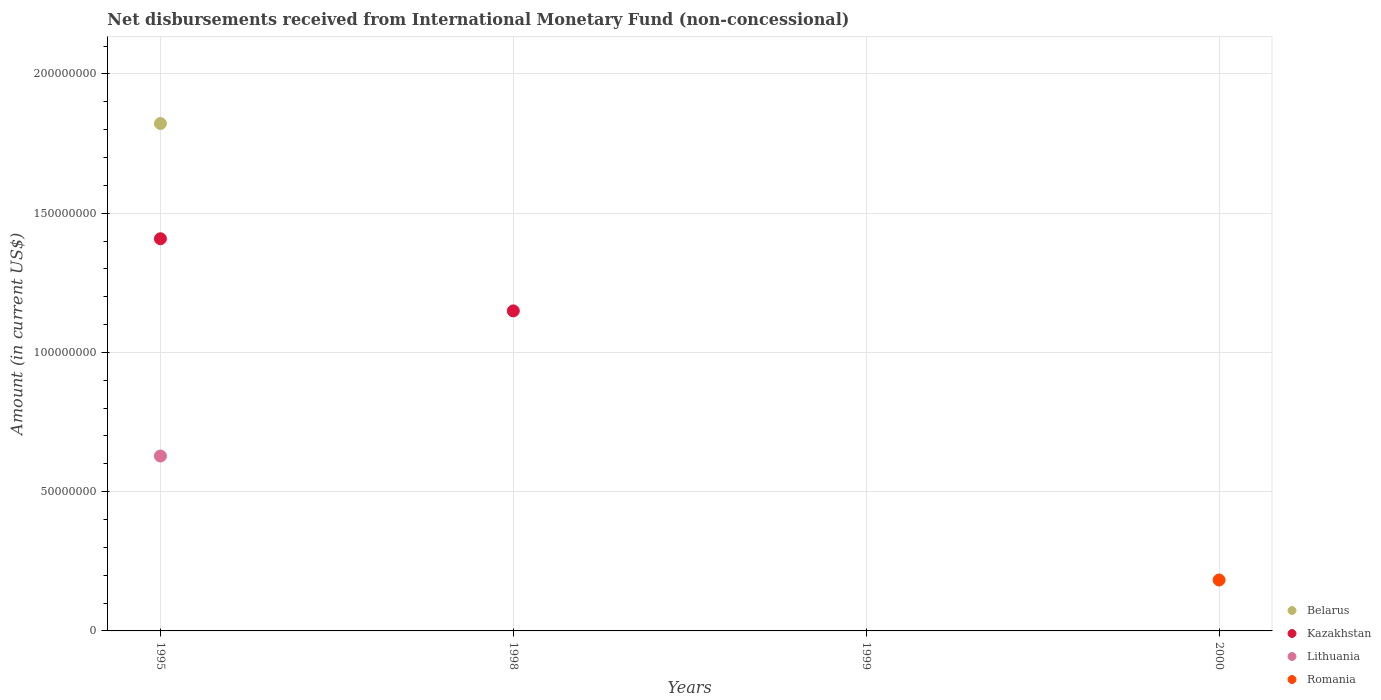Is the number of dotlines equal to the number of legend labels?
Offer a terse response. No. What is the amount of disbursements received from International Monetary Fund in Lithuania in 2000?
Your answer should be compact. 0. Across all years, what is the maximum amount of disbursements received from International Monetary Fund in Romania?
Keep it short and to the point. 1.83e+07. Across all years, what is the minimum amount of disbursements received from International Monetary Fund in Kazakhstan?
Your response must be concise. 0. In which year was the amount of disbursements received from International Monetary Fund in Romania maximum?
Keep it short and to the point. 2000. What is the total amount of disbursements received from International Monetary Fund in Kazakhstan in the graph?
Your answer should be very brief. 2.56e+08. What is the difference between the amount of disbursements received from International Monetary Fund in Kazakhstan in 1995 and that in 1998?
Offer a very short reply. 2.59e+07. What is the difference between the amount of disbursements received from International Monetary Fund in Lithuania in 1998 and the amount of disbursements received from International Monetary Fund in Romania in 2000?
Your response must be concise. -1.83e+07. What is the average amount of disbursements received from International Monetary Fund in Lithuania per year?
Provide a succinct answer. 1.57e+07. In the year 1995, what is the difference between the amount of disbursements received from International Monetary Fund in Belarus and amount of disbursements received from International Monetary Fund in Kazakhstan?
Your answer should be compact. 4.14e+07. What is the difference between the highest and the lowest amount of disbursements received from International Monetary Fund in Kazakhstan?
Your answer should be compact. 1.41e+08. Is it the case that in every year, the sum of the amount of disbursements received from International Monetary Fund in Romania and amount of disbursements received from International Monetary Fund in Belarus  is greater than the amount of disbursements received from International Monetary Fund in Lithuania?
Make the answer very short. No. Does the amount of disbursements received from International Monetary Fund in Belarus monotonically increase over the years?
Offer a terse response. No. Is the amount of disbursements received from International Monetary Fund in Kazakhstan strictly less than the amount of disbursements received from International Monetary Fund in Belarus over the years?
Make the answer very short. No. How many dotlines are there?
Offer a very short reply. 4. How many years are there in the graph?
Ensure brevity in your answer.  4. Does the graph contain grids?
Give a very brief answer. Yes. How many legend labels are there?
Give a very brief answer. 4. What is the title of the graph?
Give a very brief answer. Net disbursements received from International Monetary Fund (non-concessional). What is the label or title of the X-axis?
Give a very brief answer. Years. What is the label or title of the Y-axis?
Provide a succinct answer. Amount (in current US$). What is the Amount (in current US$) of Belarus in 1995?
Offer a very short reply. 1.82e+08. What is the Amount (in current US$) of Kazakhstan in 1995?
Your answer should be compact. 1.41e+08. What is the Amount (in current US$) of Lithuania in 1995?
Ensure brevity in your answer.  6.28e+07. What is the Amount (in current US$) of Romania in 1995?
Your response must be concise. 0. What is the Amount (in current US$) in Kazakhstan in 1998?
Offer a terse response. 1.15e+08. What is the Amount (in current US$) of Lithuania in 1998?
Your response must be concise. 0. What is the Amount (in current US$) of Romania in 1998?
Provide a succinct answer. 0. What is the Amount (in current US$) in Belarus in 1999?
Offer a very short reply. 0. What is the Amount (in current US$) in Kazakhstan in 1999?
Your answer should be compact. 0. What is the Amount (in current US$) in Lithuania in 1999?
Provide a short and direct response. 0. What is the Amount (in current US$) of Romania in 1999?
Give a very brief answer. 0. What is the Amount (in current US$) in Belarus in 2000?
Provide a short and direct response. 0. What is the Amount (in current US$) in Kazakhstan in 2000?
Your answer should be very brief. 0. What is the Amount (in current US$) in Romania in 2000?
Provide a succinct answer. 1.83e+07. Across all years, what is the maximum Amount (in current US$) of Belarus?
Provide a short and direct response. 1.82e+08. Across all years, what is the maximum Amount (in current US$) of Kazakhstan?
Make the answer very short. 1.41e+08. Across all years, what is the maximum Amount (in current US$) of Lithuania?
Give a very brief answer. 6.28e+07. Across all years, what is the maximum Amount (in current US$) in Romania?
Your answer should be compact. 1.83e+07. Across all years, what is the minimum Amount (in current US$) of Lithuania?
Offer a very short reply. 0. Across all years, what is the minimum Amount (in current US$) of Romania?
Keep it short and to the point. 0. What is the total Amount (in current US$) of Belarus in the graph?
Your answer should be very brief. 1.82e+08. What is the total Amount (in current US$) of Kazakhstan in the graph?
Keep it short and to the point. 2.56e+08. What is the total Amount (in current US$) in Lithuania in the graph?
Make the answer very short. 6.28e+07. What is the total Amount (in current US$) in Romania in the graph?
Give a very brief answer. 1.83e+07. What is the difference between the Amount (in current US$) of Kazakhstan in 1995 and that in 1998?
Ensure brevity in your answer.  2.59e+07. What is the difference between the Amount (in current US$) in Belarus in 1995 and the Amount (in current US$) in Kazakhstan in 1998?
Provide a short and direct response. 6.73e+07. What is the difference between the Amount (in current US$) in Belarus in 1995 and the Amount (in current US$) in Romania in 2000?
Give a very brief answer. 1.64e+08. What is the difference between the Amount (in current US$) of Kazakhstan in 1995 and the Amount (in current US$) of Romania in 2000?
Ensure brevity in your answer.  1.23e+08. What is the difference between the Amount (in current US$) in Lithuania in 1995 and the Amount (in current US$) in Romania in 2000?
Give a very brief answer. 4.45e+07. What is the difference between the Amount (in current US$) in Kazakhstan in 1998 and the Amount (in current US$) in Romania in 2000?
Your answer should be very brief. 9.66e+07. What is the average Amount (in current US$) in Belarus per year?
Keep it short and to the point. 4.56e+07. What is the average Amount (in current US$) in Kazakhstan per year?
Your answer should be compact. 6.39e+07. What is the average Amount (in current US$) in Lithuania per year?
Provide a succinct answer. 1.57e+07. What is the average Amount (in current US$) of Romania per year?
Make the answer very short. 4.57e+06. In the year 1995, what is the difference between the Amount (in current US$) in Belarus and Amount (in current US$) in Kazakhstan?
Keep it short and to the point. 4.14e+07. In the year 1995, what is the difference between the Amount (in current US$) of Belarus and Amount (in current US$) of Lithuania?
Your response must be concise. 1.19e+08. In the year 1995, what is the difference between the Amount (in current US$) of Kazakhstan and Amount (in current US$) of Lithuania?
Your answer should be compact. 7.80e+07. What is the ratio of the Amount (in current US$) in Kazakhstan in 1995 to that in 1998?
Ensure brevity in your answer.  1.23. What is the difference between the highest and the lowest Amount (in current US$) of Belarus?
Your response must be concise. 1.82e+08. What is the difference between the highest and the lowest Amount (in current US$) in Kazakhstan?
Ensure brevity in your answer.  1.41e+08. What is the difference between the highest and the lowest Amount (in current US$) in Lithuania?
Keep it short and to the point. 6.28e+07. What is the difference between the highest and the lowest Amount (in current US$) of Romania?
Offer a very short reply. 1.83e+07. 